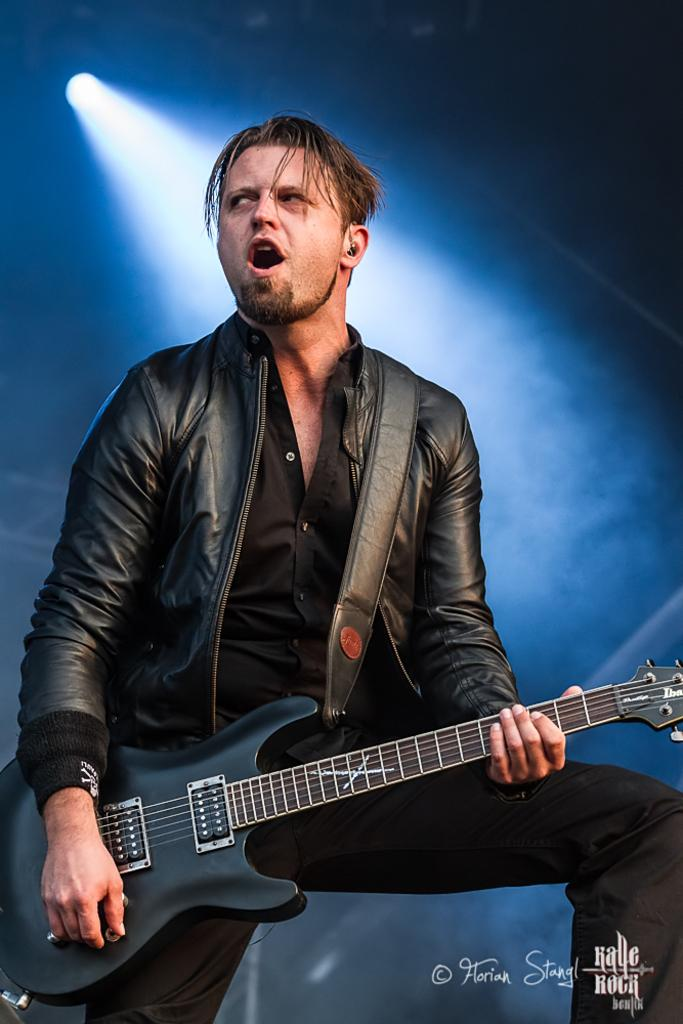Who is the main subject in the image? There is a man in the image. What is the man wearing? The man is wearing a jacket. What object is the man holding? The man is holding a guitar. What can be seen in the background of the image? There is light visible in the background of the image. What type of nation is depicted in the image? There is no nation depicted in the image; it features a man holding a guitar. Is there a bottle visible in the image? No, there is no bottle present in the image. 